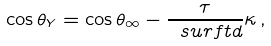<formula> <loc_0><loc_0><loc_500><loc_500>\cos { \theta _ { Y } } = \cos { \theta _ { \infty } } - \frac { \tau } { \ s u r f t { d } } \kappa \, ,</formula> 